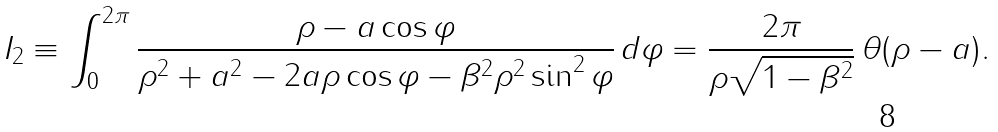<formula> <loc_0><loc_0><loc_500><loc_500>I _ { 2 } \equiv \int _ { 0 } ^ { 2 \pi } \frac { \rho - a \cos \varphi } { \rho ^ { 2 } + a ^ { 2 } - 2 a \rho \cos \varphi - \beta ^ { 2 } \rho ^ { 2 } \sin ^ { 2 } \varphi } \, d \varphi = \frac { 2 \pi } { \rho \sqrt { 1 - \beta ^ { 2 } } } \, \theta ( \rho - a ) .</formula> 